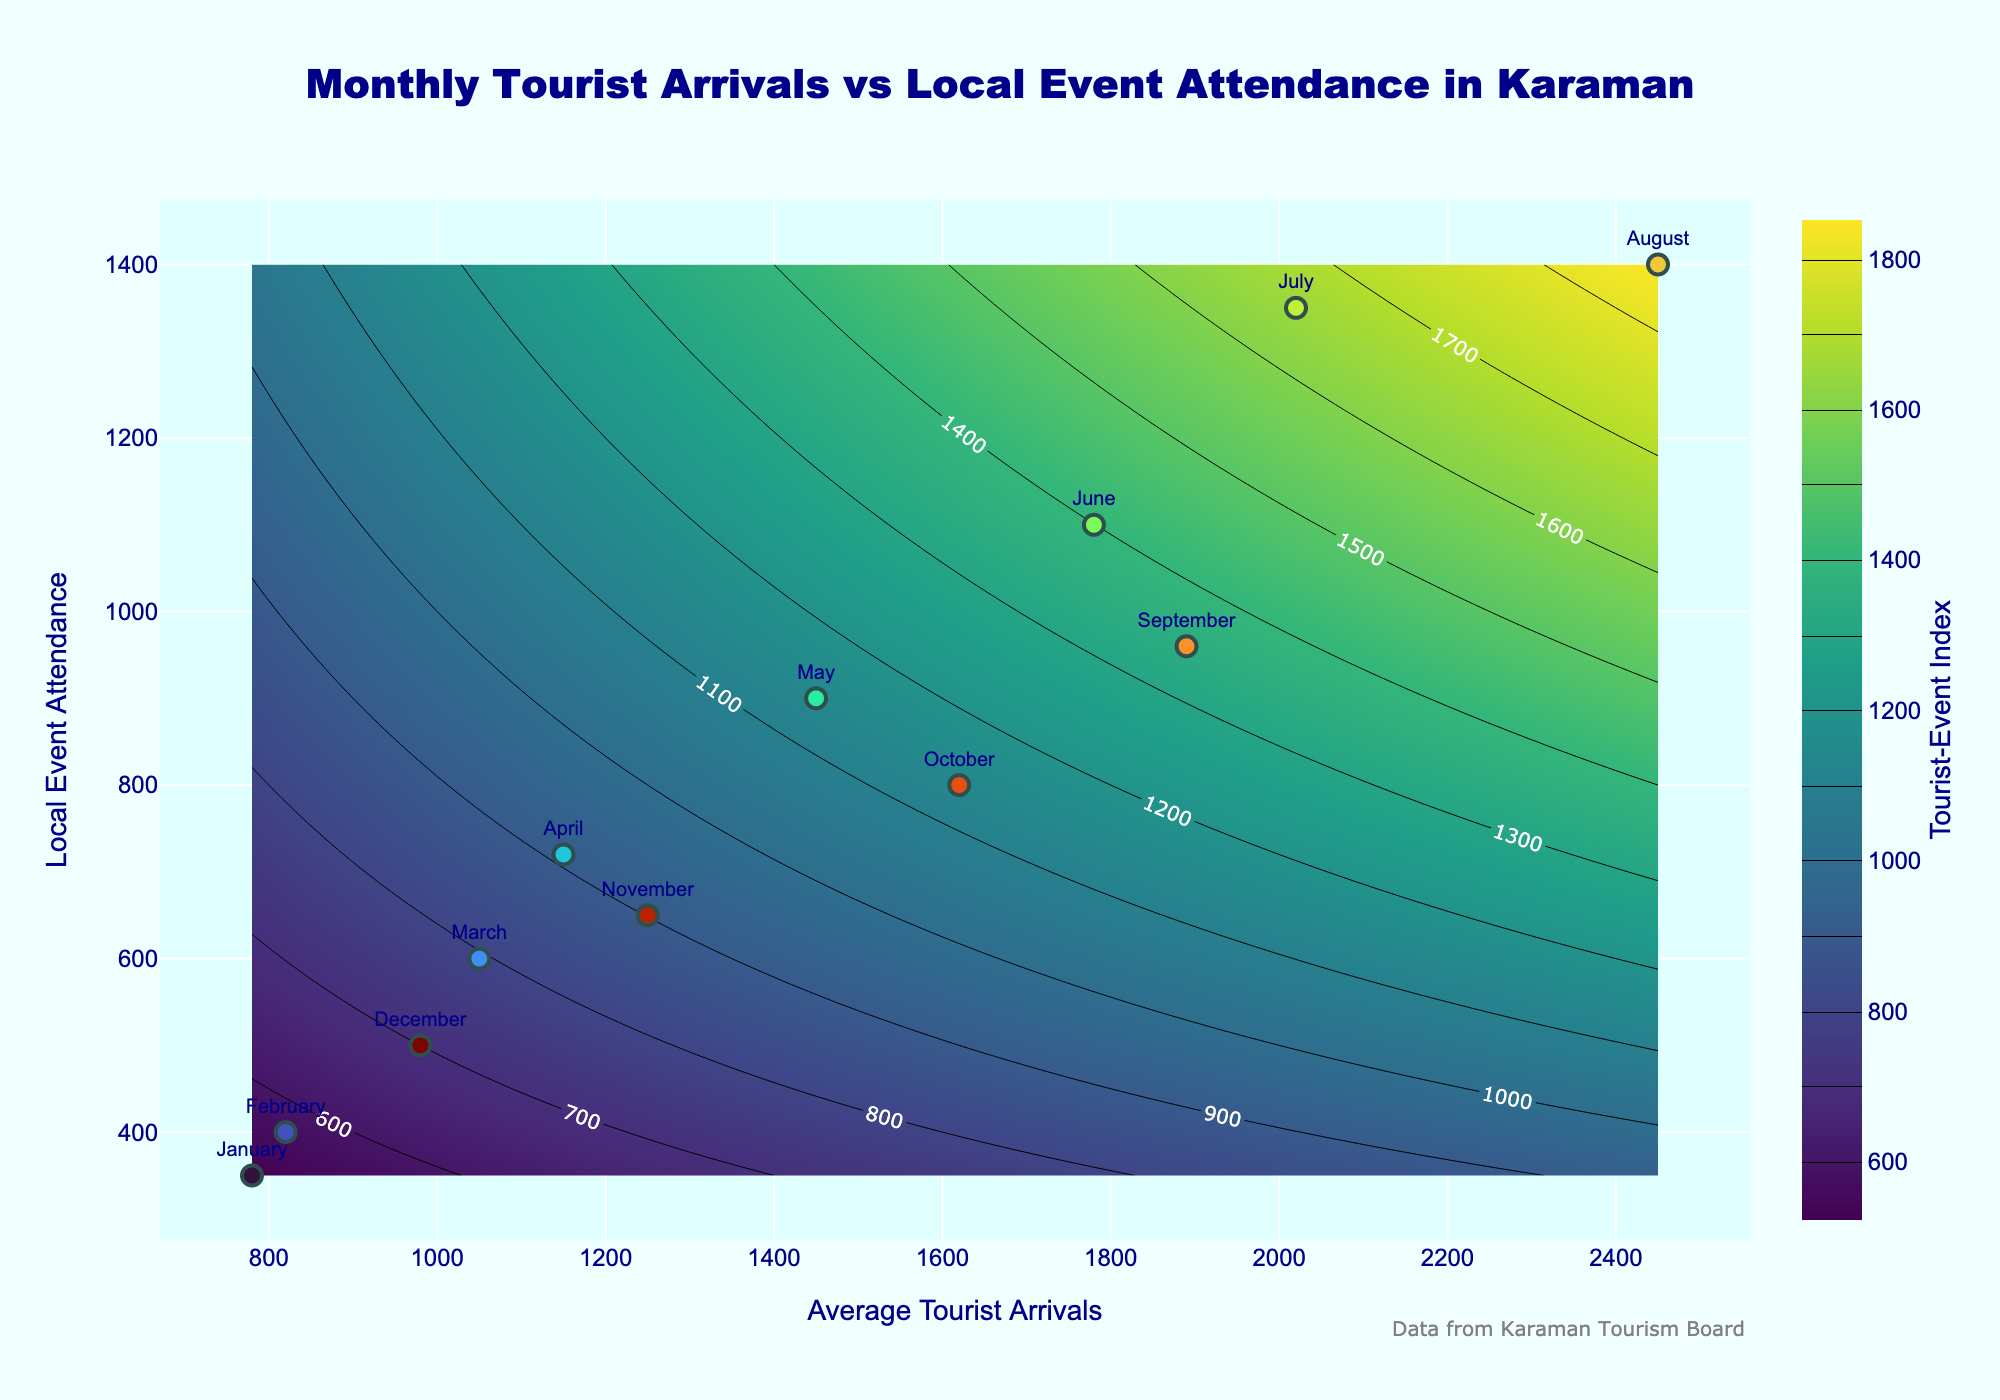What's the title of the plot? The title of the plot is written at the top center of the figure in big, bold letters. It is 'Monthly Tourist Arrivals vs Local Event Attendance in Karaman'.
Answer: Monthly Tourist Arrivals vs Local Event Attendance in Karaman What are the axes labels? The x-axis label is 'Average Tourist Arrivals' which denotes the average number of tourists arriving each month, and the y-axis label is 'Local Event Attendance' which indicates the number of people attending local events each month.
Answer: Average Tourist Arrivals and Local Event Attendance How many data points are plotted on the scatter plot? There is one scatter point for each month of the year, from January to December, hence there are 12 data points plotted on the scatter plot.
Answer: 12 Which month has the highest tourist arrivals? The scatter plot shows that the month of August has the point farthest to the right on the x-axis, indicating the highest average tourist arrivals.
Answer: August Which month has the highest local event attendance? The scatter plot shows that the month of August has the point farthest to the top on the y-axis, indicating the highest local event attendance.
Answer: August Which months have both tourist arrivals and local event attendance greater than 1500? By looking at the scatter plot, August and July are positioned to the right of the 1500 average tourist arrivals line and above the 1500 local event attendance line.
Answer: August and July What is the correlation between average tourist arrivals and local event attendance? Observing the direction in which data points cluster as well as following the contour lines, we see a positive correlation where higher tourist arrivals are associated with higher local event attendance.
Answer: Positive correlation What is the average value of the Tourist-Event Index when tourist arrivals are 1500 and local event attendance is 800? On the contour plot, locate the values near 1500 on the x-axis and 800 on the y-axis. The z-value or Tourist-Event Index can be estimated from the nearby contour line value which seems to be around 34.6.
Answer: Approximately 34.6 Which month lies closest to the Tourist-Event Index of 50? By checking the contour lines, the month of July seems to lie near the contour line corresponding to a Tourist-Event Index of 50.
Answer: July 